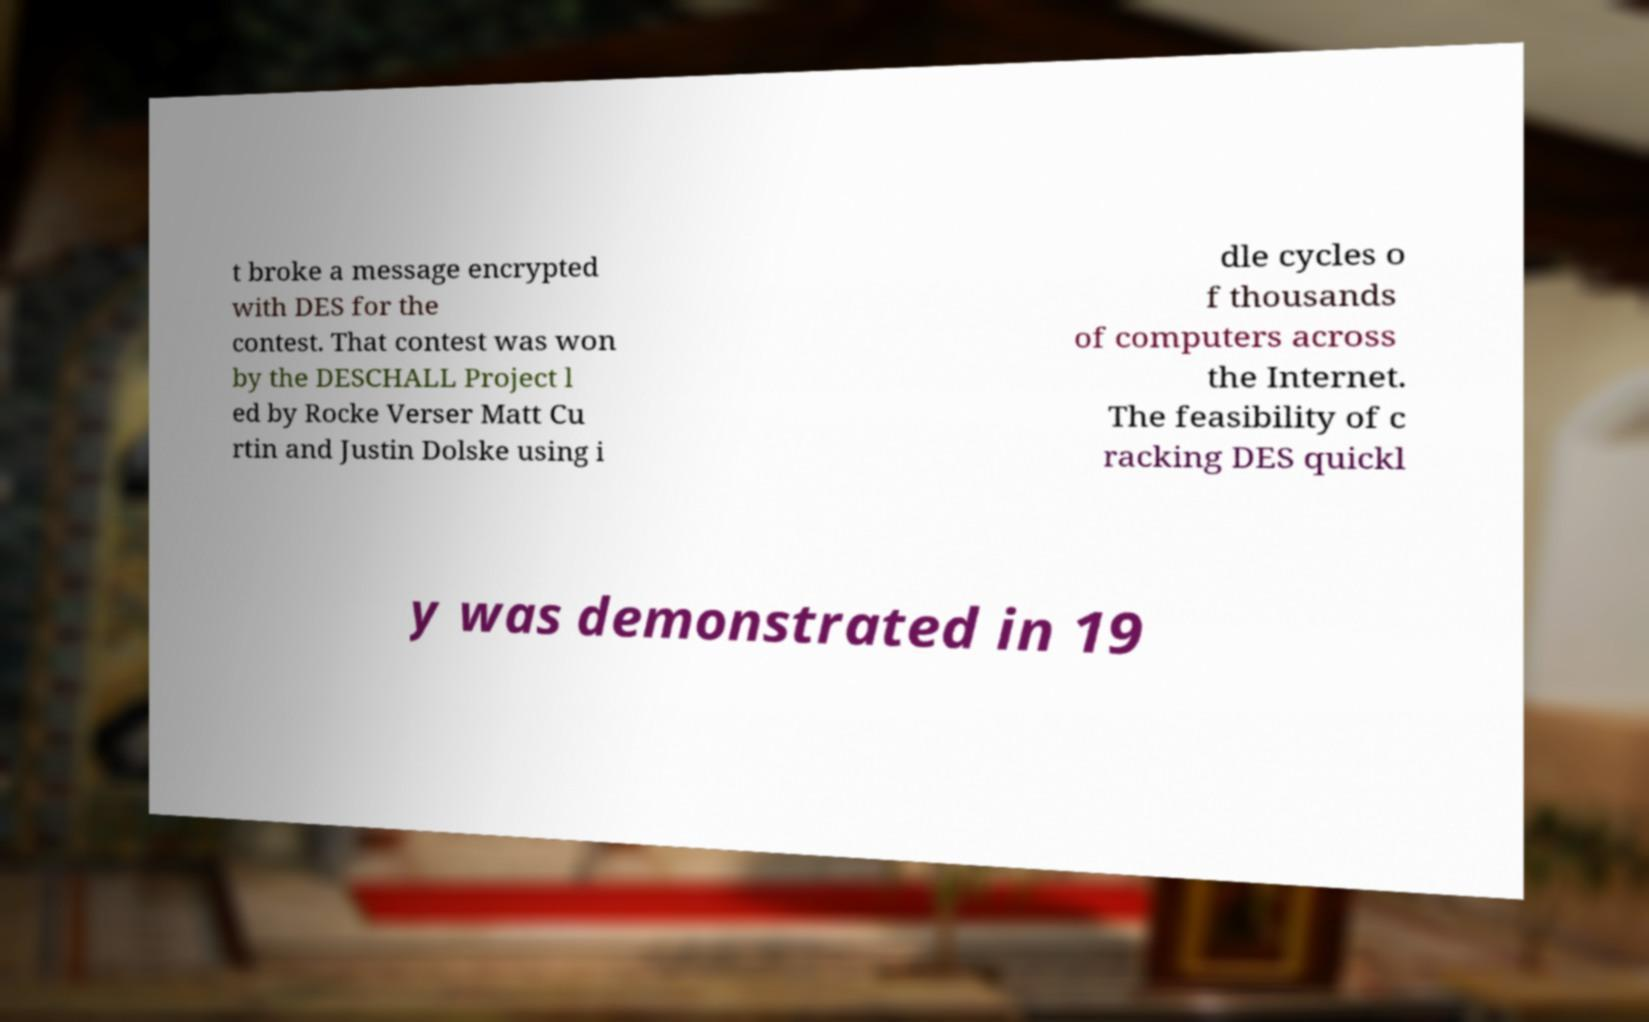Please identify and transcribe the text found in this image. t broke a message encrypted with DES for the contest. That contest was won by the DESCHALL Project l ed by Rocke Verser Matt Cu rtin and Justin Dolske using i dle cycles o f thousands of computers across the Internet. The feasibility of c racking DES quickl y was demonstrated in 19 